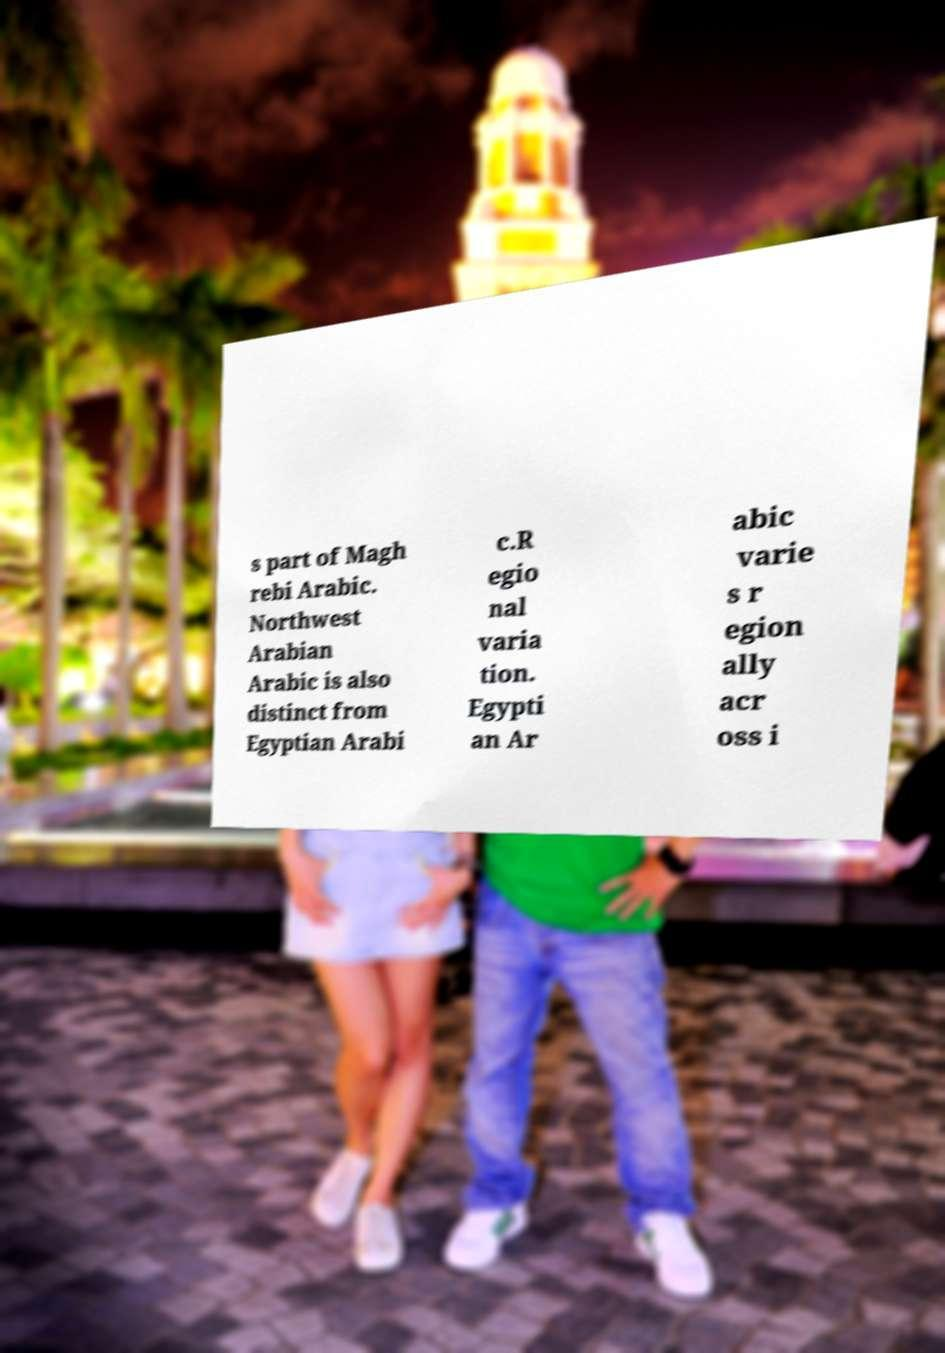Could you extract and type out the text from this image? s part of Magh rebi Arabic. Northwest Arabian Arabic is also distinct from Egyptian Arabi c.R egio nal varia tion. Egypti an Ar abic varie s r egion ally acr oss i 